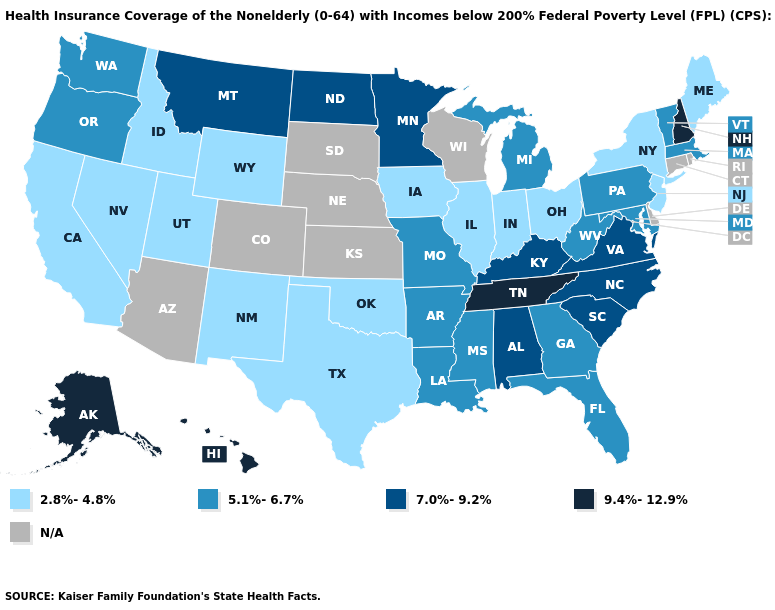What is the value of Arizona?
Write a very short answer. N/A. What is the value of Connecticut?
Short answer required. N/A. Does the first symbol in the legend represent the smallest category?
Be succinct. Yes. What is the value of Maine?
Write a very short answer. 2.8%-4.8%. Among the states that border Arkansas , which have the lowest value?
Be succinct. Oklahoma, Texas. What is the lowest value in the USA?
Keep it brief. 2.8%-4.8%. What is the highest value in the MidWest ?
Quick response, please. 7.0%-9.2%. Name the states that have a value in the range N/A?
Keep it brief. Arizona, Colorado, Connecticut, Delaware, Kansas, Nebraska, Rhode Island, South Dakota, Wisconsin. Which states have the lowest value in the South?
Give a very brief answer. Oklahoma, Texas. Does Michigan have the highest value in the USA?
Answer briefly. No. Does the map have missing data?
Keep it brief. Yes. What is the value of Delaware?
Be succinct. N/A. Does the map have missing data?
Give a very brief answer. Yes. What is the lowest value in the USA?
Short answer required. 2.8%-4.8%. 